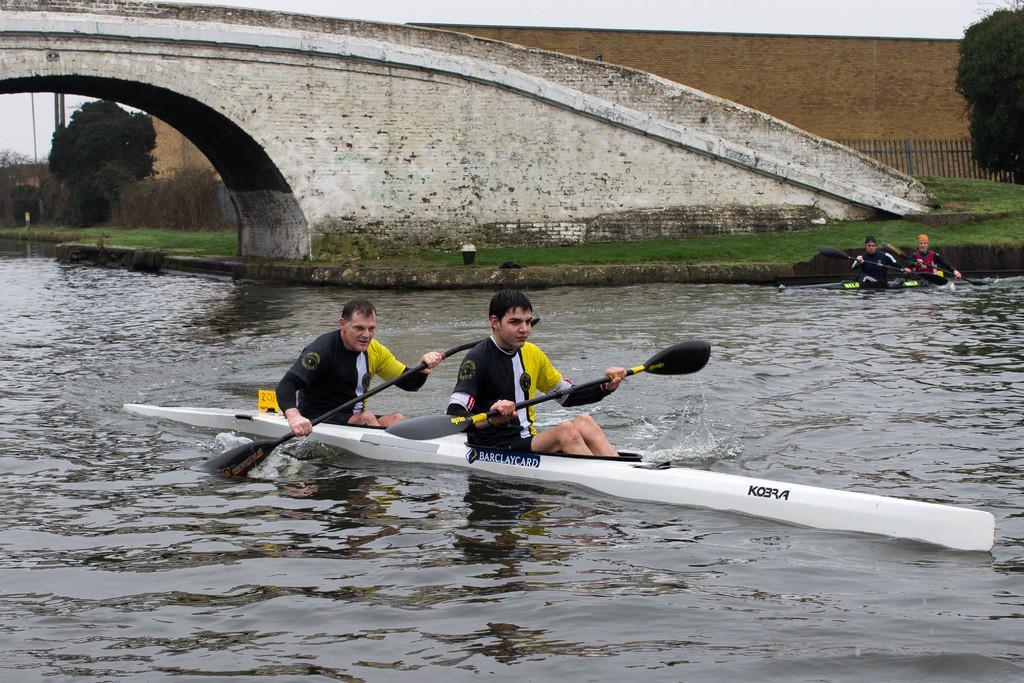In one or two sentences, can you explain what this image depicts? In this there are people rowing boats on the water and we can see bridge and grass. In the background of the image we can see trees, fence, wall and sky. 